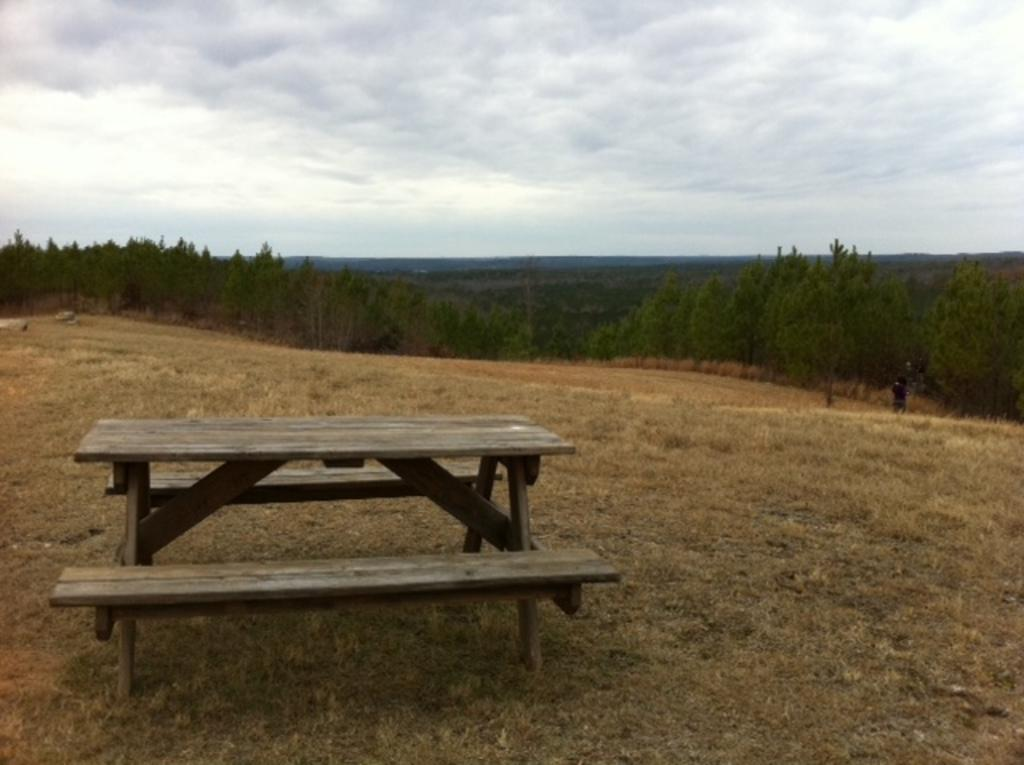What type of seating is present in the image? There is a bench in the image. Where is the bench located? The bench is on the ground. What can be seen in the distance behind the bench? Mountains and trees are visible in the background of the image. How many toes can be seen on the aunt's foot in the image? There is no aunt or foot present in the image, so it is not possible to determine the number of toes. 